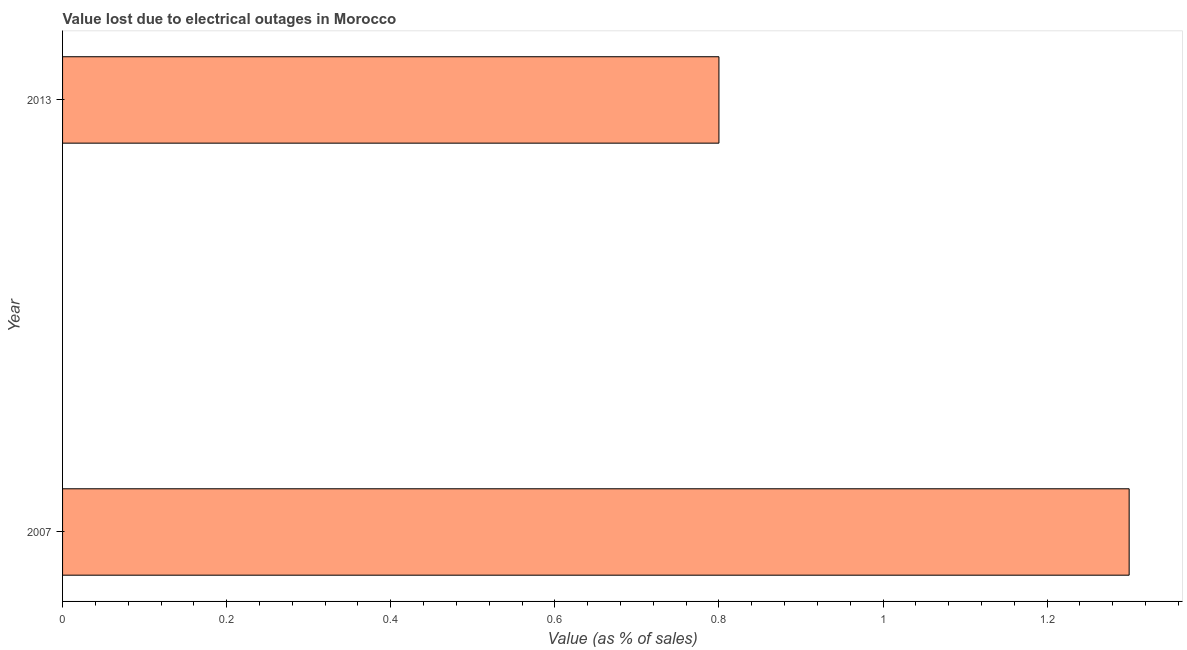Does the graph contain grids?
Your response must be concise. No. What is the title of the graph?
Your answer should be compact. Value lost due to electrical outages in Morocco. What is the label or title of the X-axis?
Offer a very short reply. Value (as % of sales). What is the label or title of the Y-axis?
Provide a succinct answer. Year. What is the value lost due to electrical outages in 2007?
Make the answer very short. 1.3. Across all years, what is the maximum value lost due to electrical outages?
Your response must be concise. 1.3. Across all years, what is the minimum value lost due to electrical outages?
Offer a very short reply. 0.8. What is the sum of the value lost due to electrical outages?
Offer a very short reply. 2.1. What is the difference between the value lost due to electrical outages in 2007 and 2013?
Provide a short and direct response. 0.5. What is the average value lost due to electrical outages per year?
Offer a terse response. 1.05. What is the median value lost due to electrical outages?
Offer a very short reply. 1.05. What is the ratio of the value lost due to electrical outages in 2007 to that in 2013?
Give a very brief answer. 1.62. Is the value lost due to electrical outages in 2007 less than that in 2013?
Your answer should be compact. No. How many bars are there?
Your answer should be compact. 2. Are the values on the major ticks of X-axis written in scientific E-notation?
Keep it short and to the point. No. What is the Value (as % of sales) in 2007?
Your response must be concise. 1.3. What is the Value (as % of sales) of 2013?
Keep it short and to the point. 0.8. What is the difference between the Value (as % of sales) in 2007 and 2013?
Offer a very short reply. 0.5. What is the ratio of the Value (as % of sales) in 2007 to that in 2013?
Ensure brevity in your answer.  1.62. 